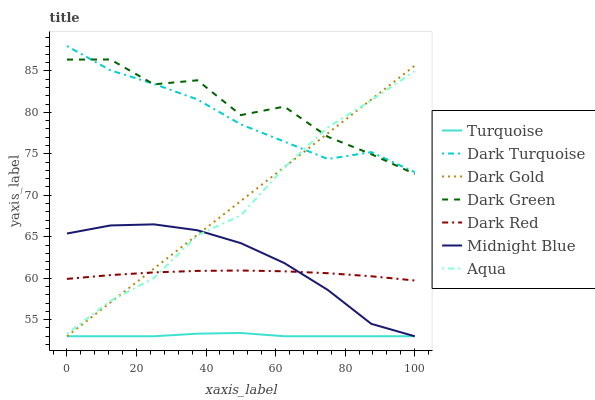Does Turquoise have the minimum area under the curve?
Answer yes or no. Yes. Does Dark Green have the maximum area under the curve?
Answer yes or no. Yes. Does Midnight Blue have the minimum area under the curve?
Answer yes or no. No. Does Midnight Blue have the maximum area under the curve?
Answer yes or no. No. Is Dark Gold the smoothest?
Answer yes or no. Yes. Is Dark Green the roughest?
Answer yes or no. Yes. Is Midnight Blue the smoothest?
Answer yes or no. No. Is Midnight Blue the roughest?
Answer yes or no. No. Does Turquoise have the lowest value?
Answer yes or no. Yes. Does Dark Turquoise have the lowest value?
Answer yes or no. No. Does Dark Turquoise have the highest value?
Answer yes or no. Yes. Does Midnight Blue have the highest value?
Answer yes or no. No. Is Midnight Blue less than Dark Green?
Answer yes or no. Yes. Is Dark Green greater than Dark Red?
Answer yes or no. Yes. Does Dark Gold intersect Dark Red?
Answer yes or no. Yes. Is Dark Gold less than Dark Red?
Answer yes or no. No. Is Dark Gold greater than Dark Red?
Answer yes or no. No. Does Midnight Blue intersect Dark Green?
Answer yes or no. No. 